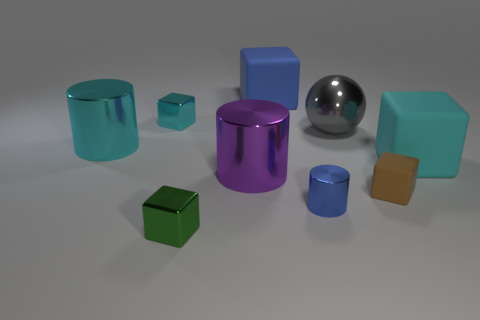What is the size of the blue thing that is in front of the big metallic sphere?
Offer a terse response. Small. There is a cylinder left of the small object behind the gray thing; how big is it?
Provide a short and direct response. Large. There is a cyan block that is the same size as the green object; what is it made of?
Provide a succinct answer. Metal. There is a cyan matte cube; are there any green metal blocks behind it?
Provide a succinct answer. No. Are there the same number of cyan metallic cylinders that are on the right side of the cyan metal cylinder and tiny blue rubber balls?
Your answer should be compact. Yes. What is the shape of the purple metallic object that is the same size as the blue matte thing?
Offer a very short reply. Cylinder. What material is the tiny cylinder?
Keep it short and to the point. Metal. There is a large thing that is right of the large blue rubber cube and behind the cyan metal cylinder; what is its color?
Provide a short and direct response. Gray. Is the number of cyan rubber objects in front of the purple cylinder the same as the number of big blue objects that are in front of the large gray object?
Provide a succinct answer. Yes. The sphere that is made of the same material as the small blue object is what color?
Offer a very short reply. Gray. 